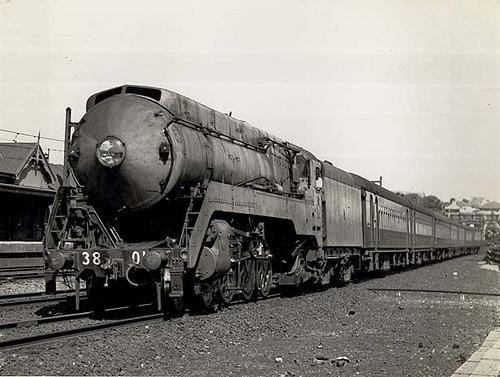How old do you think this train is?
Answer briefly. 50. Is the photo in color?
Keep it brief. No. How many people are pictured?
Quick response, please. 0. Is this an HDR image?
Keep it brief. No. What is the engine number?
Keep it brief. 38. Is this train going through the countryside?
Short answer required. No. Is the light on the train engine on?
Keep it brief. No. 